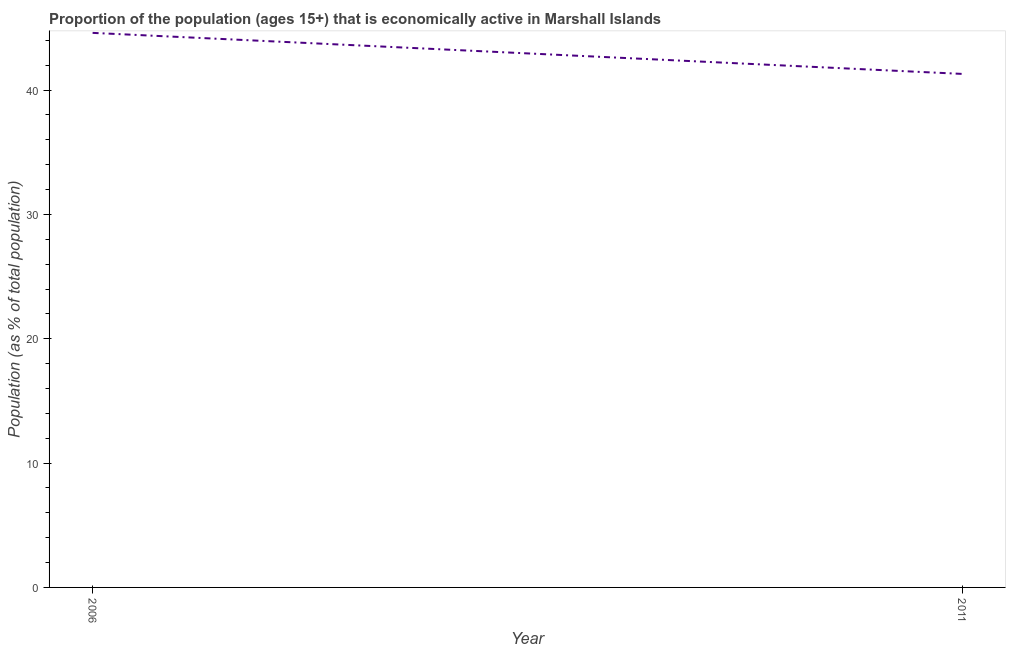What is the percentage of economically active population in 2011?
Provide a succinct answer. 41.3. Across all years, what is the maximum percentage of economically active population?
Offer a very short reply. 44.6. Across all years, what is the minimum percentage of economically active population?
Your response must be concise. 41.3. In which year was the percentage of economically active population maximum?
Provide a succinct answer. 2006. In which year was the percentage of economically active population minimum?
Offer a terse response. 2011. What is the sum of the percentage of economically active population?
Your answer should be very brief. 85.9. What is the difference between the percentage of economically active population in 2006 and 2011?
Make the answer very short. 3.3. What is the average percentage of economically active population per year?
Ensure brevity in your answer.  42.95. What is the median percentage of economically active population?
Keep it short and to the point. 42.95. In how many years, is the percentage of economically active population greater than 2 %?
Offer a terse response. 2. Do a majority of the years between 2006 and 2011 (inclusive) have percentage of economically active population greater than 30 %?
Provide a short and direct response. Yes. What is the ratio of the percentage of economically active population in 2006 to that in 2011?
Your answer should be very brief. 1.08. Does the percentage of economically active population monotonically increase over the years?
Provide a short and direct response. No. Does the graph contain grids?
Your answer should be very brief. No. What is the title of the graph?
Keep it short and to the point. Proportion of the population (ages 15+) that is economically active in Marshall Islands. What is the label or title of the Y-axis?
Keep it short and to the point. Population (as % of total population). What is the Population (as % of total population) in 2006?
Make the answer very short. 44.6. What is the Population (as % of total population) in 2011?
Keep it short and to the point. 41.3. What is the difference between the Population (as % of total population) in 2006 and 2011?
Make the answer very short. 3.3. What is the ratio of the Population (as % of total population) in 2006 to that in 2011?
Provide a succinct answer. 1.08. 